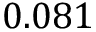<formula> <loc_0><loc_0><loc_500><loc_500>0 . 0 8 1</formula> 